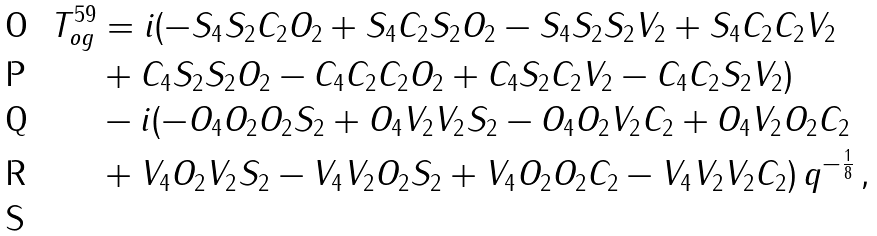<formula> <loc_0><loc_0><loc_500><loc_500>T _ { o g } ^ { 5 9 } & = i ( - S _ { 4 } S _ { 2 } C _ { 2 } O _ { 2 } + S _ { 4 } C _ { 2 } S _ { 2 } O _ { 2 } - S _ { 4 } S _ { 2 } S _ { 2 } V _ { 2 } + S _ { 4 } C _ { 2 } C _ { 2 } V _ { 2 } \\ & + C _ { 4 } S _ { 2 } S _ { 2 } O _ { 2 } - C _ { 4 } C _ { 2 } C _ { 2 } O _ { 2 } + C _ { 4 } S _ { 2 } C _ { 2 } V _ { 2 } - C _ { 4 } C _ { 2 } S _ { 2 } V _ { 2 } ) \\ & - i ( - O _ { 4 } O _ { 2 } O _ { 2 } S _ { 2 } + O _ { 4 } V _ { 2 } V _ { 2 } S _ { 2 } - O _ { 4 } O _ { 2 } V _ { 2 } C _ { 2 } + O _ { 4 } V _ { 2 } O _ { 2 } C _ { 2 } \\ & + V _ { 4 } O _ { 2 } V _ { 2 } S _ { 2 } - V _ { 4 } V _ { 2 } O _ { 2 } S _ { 2 } + V _ { 4 } O _ { 2 } O _ { 2 } C _ { 2 } - V _ { 4 } V _ { 2 } V _ { 2 } C _ { 2 } ) \, q ^ { - \frac { 1 } { 8 } } \, , \\</formula> 